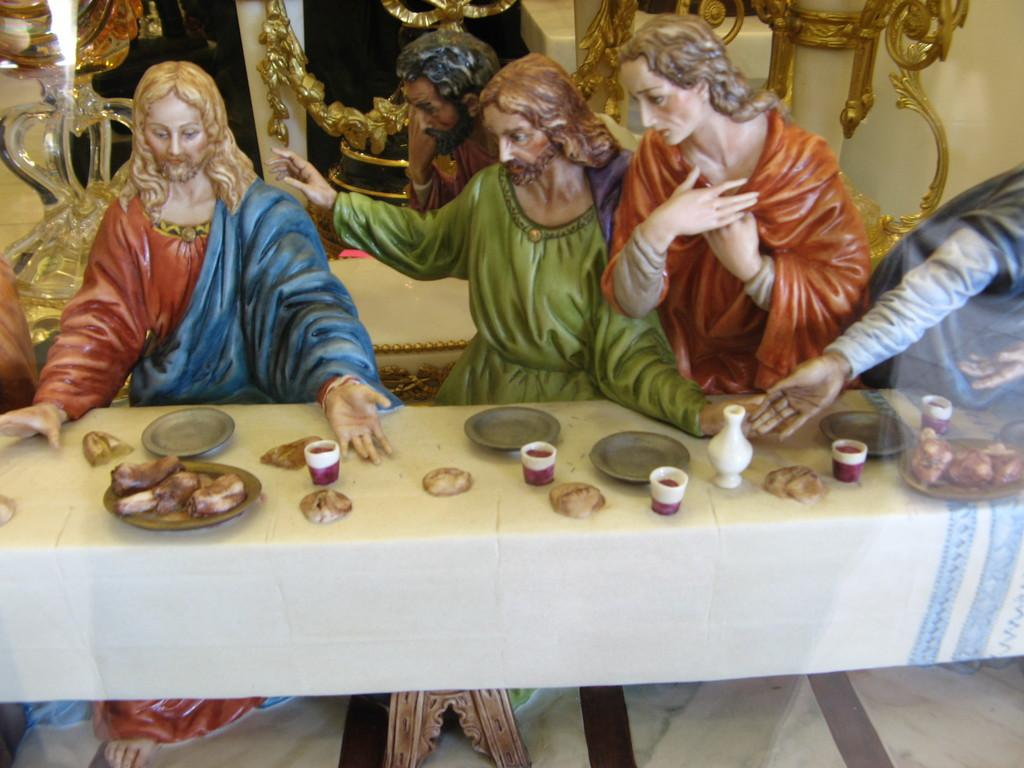What type of objects are depicted in the image? There are statues of persons in the image. What can be seen behind the statues? There are objects behind the statues. Are there any objects in the foreground of the image? Yes, there is a group of objects on a table in the foreground of the image. What type of grass is growing around the statues in the image? There is no grass present in the image; it features statues and objects. What tool is being used by the statues in the image? The statues are not depicted as using any tools, such as a hammer, in the image. 